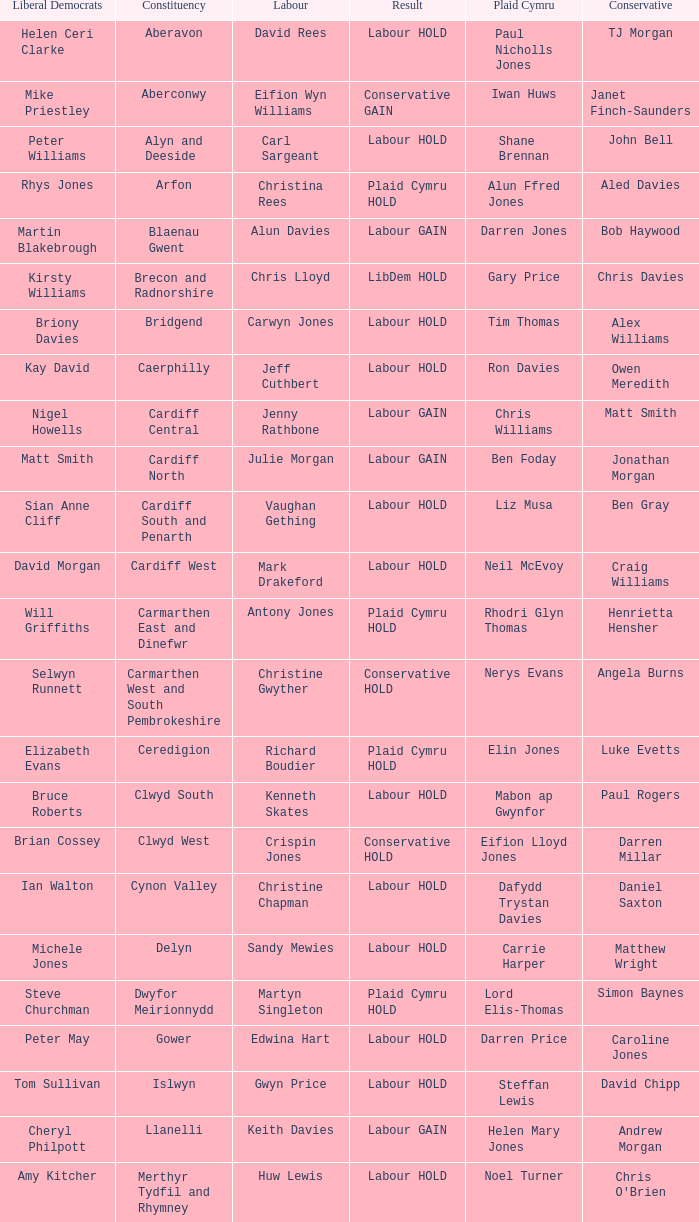In what constituency was the result labour hold and Liberal democrat Elizabeth Newton won? Newport West. Would you mind parsing the complete table? {'header': ['Liberal Democrats', 'Constituency', 'Labour', 'Result', 'Plaid Cymru', 'Conservative'], 'rows': [['Helen Ceri Clarke', 'Aberavon', 'David Rees', 'Labour HOLD', 'Paul Nicholls Jones', 'TJ Morgan'], ['Mike Priestley', 'Aberconwy', 'Eifion Wyn Williams', 'Conservative GAIN', 'Iwan Huws', 'Janet Finch-Saunders'], ['Peter Williams', 'Alyn and Deeside', 'Carl Sargeant', 'Labour HOLD', 'Shane Brennan', 'John Bell'], ['Rhys Jones', 'Arfon', 'Christina Rees', 'Plaid Cymru HOLD', 'Alun Ffred Jones', 'Aled Davies'], ['Martin Blakebrough', 'Blaenau Gwent', 'Alun Davies', 'Labour GAIN', 'Darren Jones', 'Bob Haywood'], ['Kirsty Williams', 'Brecon and Radnorshire', 'Chris Lloyd', 'LibDem HOLD', 'Gary Price', 'Chris Davies'], ['Briony Davies', 'Bridgend', 'Carwyn Jones', 'Labour HOLD', 'Tim Thomas', 'Alex Williams'], ['Kay David', 'Caerphilly', 'Jeff Cuthbert', 'Labour HOLD', 'Ron Davies', 'Owen Meredith'], ['Nigel Howells', 'Cardiff Central', 'Jenny Rathbone', 'Labour GAIN', 'Chris Williams', 'Matt Smith'], ['Matt Smith', 'Cardiff North', 'Julie Morgan', 'Labour GAIN', 'Ben Foday', 'Jonathan Morgan'], ['Sian Anne Cliff', 'Cardiff South and Penarth', 'Vaughan Gething', 'Labour HOLD', 'Liz Musa', 'Ben Gray'], ['David Morgan', 'Cardiff West', 'Mark Drakeford', 'Labour HOLD', 'Neil McEvoy', 'Craig Williams'], ['Will Griffiths', 'Carmarthen East and Dinefwr', 'Antony Jones', 'Plaid Cymru HOLD', 'Rhodri Glyn Thomas', 'Henrietta Hensher'], ['Selwyn Runnett', 'Carmarthen West and South Pembrokeshire', 'Christine Gwyther', 'Conservative HOLD', 'Nerys Evans', 'Angela Burns'], ['Elizabeth Evans', 'Ceredigion', 'Richard Boudier', 'Plaid Cymru HOLD', 'Elin Jones', 'Luke Evetts'], ['Bruce Roberts', 'Clwyd South', 'Kenneth Skates', 'Labour HOLD', 'Mabon ap Gwynfor', 'Paul Rogers'], ['Brian Cossey', 'Clwyd West', 'Crispin Jones', 'Conservative HOLD', 'Eifion Lloyd Jones', 'Darren Millar'], ['Ian Walton', 'Cynon Valley', 'Christine Chapman', 'Labour HOLD', 'Dafydd Trystan Davies', 'Daniel Saxton'], ['Michele Jones', 'Delyn', 'Sandy Mewies', 'Labour HOLD', 'Carrie Harper', 'Matthew Wright'], ['Steve Churchman', 'Dwyfor Meirionnydd', 'Martyn Singleton', 'Plaid Cymru HOLD', 'Lord Elis-Thomas', 'Simon Baynes'], ['Peter May', 'Gower', 'Edwina Hart', 'Labour HOLD', 'Darren Price', 'Caroline Jones'], ['Tom Sullivan', 'Islwyn', 'Gwyn Price', 'Labour HOLD', 'Steffan Lewis', 'David Chipp'], ['Cheryl Philpott', 'Llanelli', 'Keith Davies', 'Labour GAIN', 'Helen Mary Jones', 'Andrew Morgan'], ['Amy Kitcher', 'Merthyr Tydfil and Rhymney', 'Huw Lewis', 'Labour HOLD', 'Noel Turner', "Chris O'Brien"], ['Janet Ellard', 'Monmouth', 'Mark Whitcutt', 'Conservative HOLD', 'Fiona Cross', 'Nick Ramsay'], ['Wyn Williams', 'Montgomeryshire', 'Nick Colbourne', 'Conservative GAIN', 'David Senior', 'Russell George'], ['Matthew McCarthy', 'Neath', 'Gwenda Thomas', 'Labour HOLD', 'Alun Llewellyn', 'Alex Powell'], ['Ed Townsend', 'Newport East', 'John Griffiths', 'Labour HOLD', 'Chris Paul', 'Nick Webb'], ['Elizabeth Newton', 'Newport West', 'Rosemary Butler', 'Labour HOLD', 'Lyndon Binding', 'David Williams'], ['Gerald Francis', 'Ogmore', 'Janice Gregory', 'Labour HOLD', 'Danny Clark', 'Martyn Hughes'], ['Mike Powell', 'Pontypridd', 'Mick Antoniw', 'Labour HOLD', 'Ioan Bellin', 'Joel James'], ['Bob Kilmister', 'Preseli Pembrokeshire', 'Terry Mills', 'Conservative HOLD', 'Rhys Sinnett', 'Paul Davies'], ['George Summers', 'Rhondda', 'Leighton Andrews', 'Labour HOLD', 'Sera Evans-Fear', 'James Eric Jefferys'], ['Sam Samuel', 'Swansea East', 'Michael Hedges', 'Labour HOLD', 'Dic Jones', 'Dan Boucher'], ['Rob Speht', 'Swansea West', 'Julie James', 'Labour HOLD', 'Carl Harris', 'Stephen Jenkins'], ['Will Griffiths', 'Torfaen', 'Lynne Neagle', 'Labour HOLD', 'Jeff Rees', 'Natasha Asghar'], ['Heather Prydderch', 'Vale of Clwyd', 'Ann Jones', 'Labour HOLD', 'Alun Lloyd Jones', 'Ian Gunning'], ['Damian Chick', 'Vale of Glamorgan', 'Jane Hutt', 'Labour HOLD', 'Ian Johnson', 'Angela Jones-Evans'], ['Bill Brereton', 'Wrexham', 'Lesley Griffiths', 'Labour HOLD', 'Marc Jones', 'John Marek'], ['Rhys Taylor', 'Ynys Môn', 'Joe Lock', 'Plaid Cymru HOLD', 'Ieuan Wyn Jones', 'Paul Williams']]} 